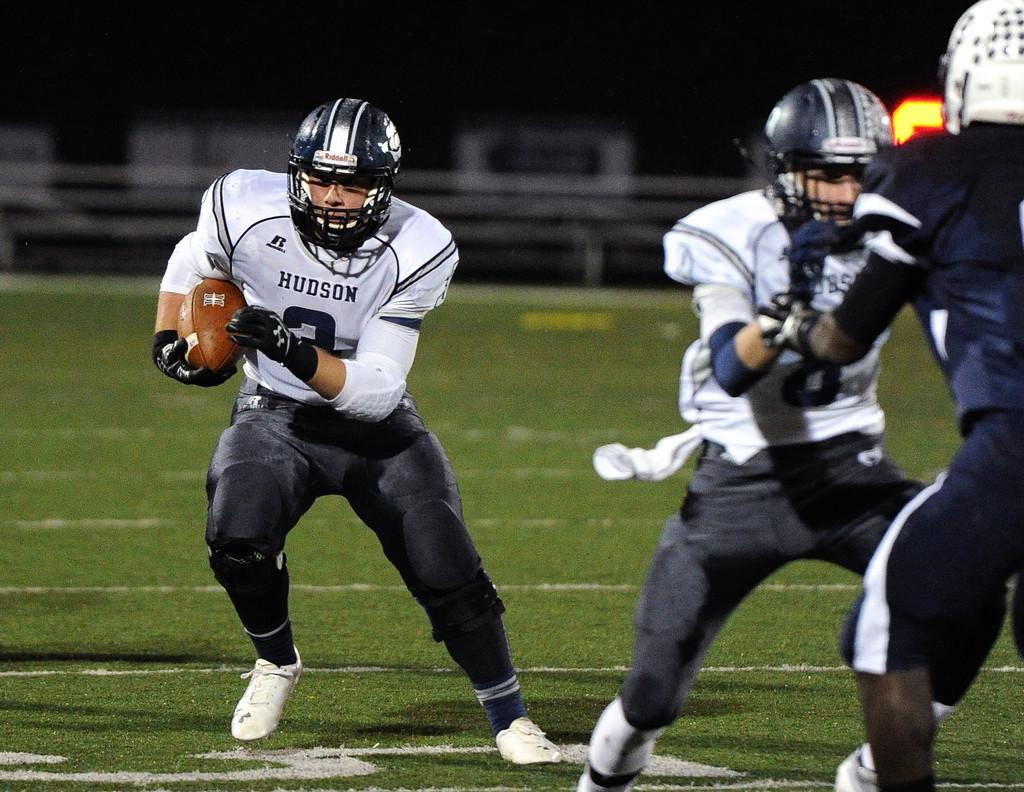How many people are in the image? There are three men in the image. What activity are the men engaged in? The men are playing American football. What type of clothing are the men wearing? The men are wearing sports dress. What protective gear are the men wearing? The men are wearing helmets. What is the surface beneath the men in the image? There is green grass at the bottom of the image. How would you describe the background of the image? The background of the image is blurred. How many kittens are playing with a marble in the image? There are no kittens or marbles present in the image; it features three men playing American football. What type of drink is being consumed by the men in the image? There is no drink visible in the image; the men are focused on playing American football. 